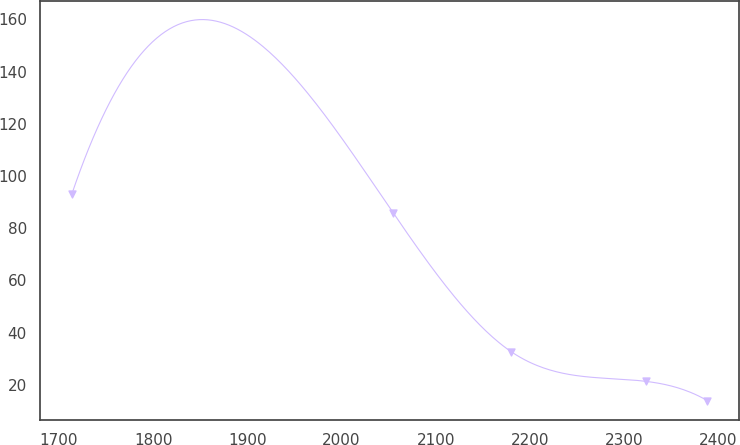Convert chart to OTSL. <chart><loc_0><loc_0><loc_500><loc_500><line_chart><ecel><fcel>Unnamed: 1<nl><fcel>1713.63<fcel>93.07<nl><fcel>2055.08<fcel>85.74<nl><fcel>2179.87<fcel>32.78<nl><fcel>2323.01<fcel>21.37<nl><fcel>2388.09<fcel>14.04<nl></chart> 